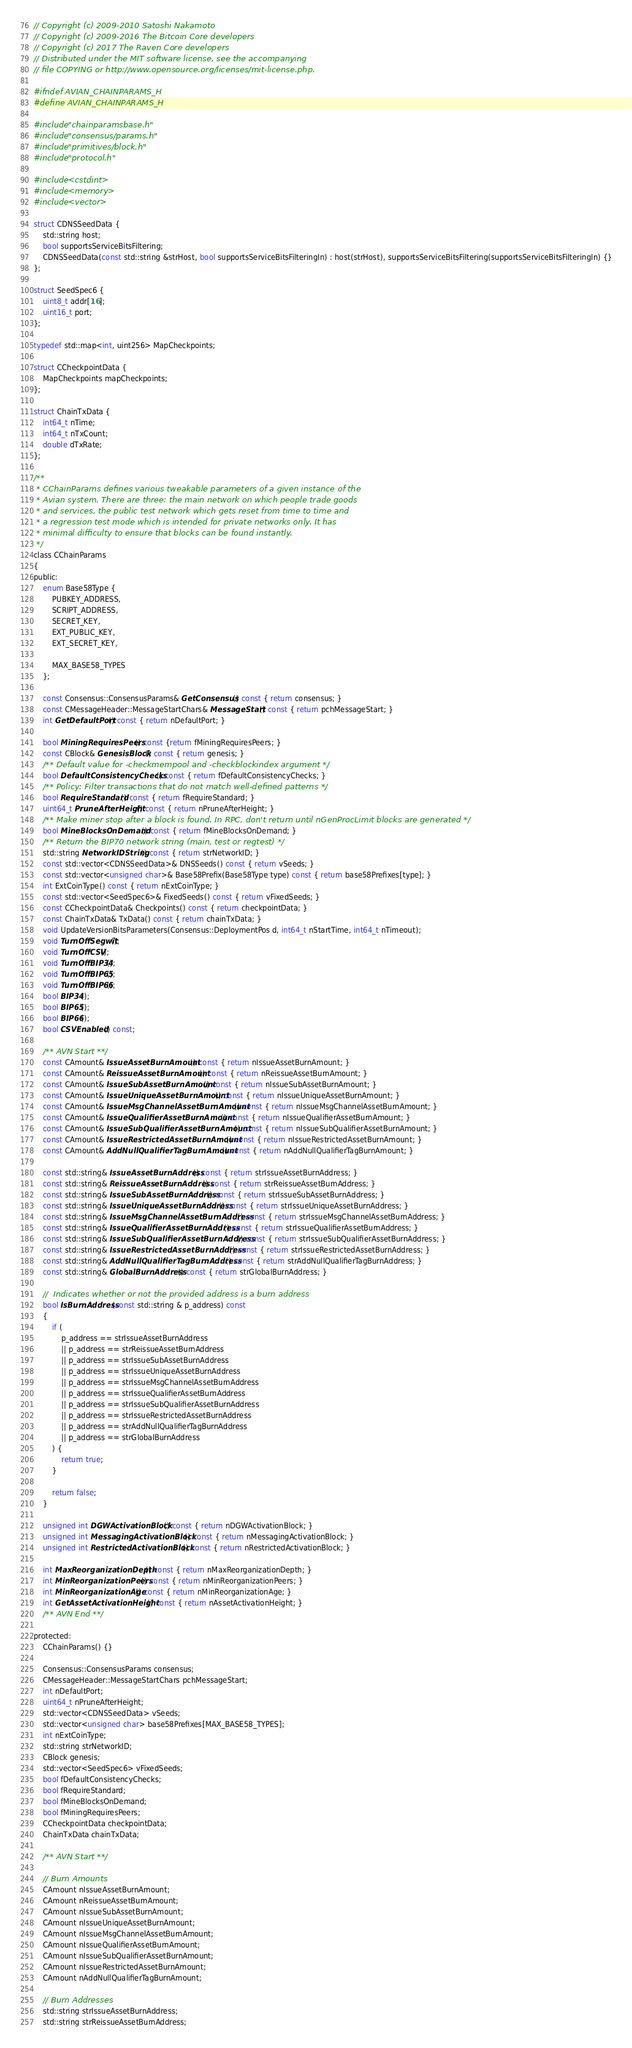<code> <loc_0><loc_0><loc_500><loc_500><_C_>// Copyright (c) 2009-2010 Satoshi Nakamoto
// Copyright (c) 2009-2016 The Bitcoin Core developers
// Copyright (c) 2017 The Raven Core developers
// Distributed under the MIT software license, see the accompanying
// file COPYING or http://www.opensource.org/licenses/mit-license.php.

#ifndef AVIAN_CHAINPARAMS_H
#define AVIAN_CHAINPARAMS_H

#include "chainparamsbase.h"
#include "consensus/params.h"
#include "primitives/block.h"
#include "protocol.h"

#include <cstdint>
#include <memory>
#include <vector>

struct CDNSSeedData {
    std::string host;
    bool supportsServiceBitsFiltering;
    CDNSSeedData(const std::string &strHost, bool supportsServiceBitsFilteringIn) : host(strHost), supportsServiceBitsFiltering(supportsServiceBitsFilteringIn) {}
};

struct SeedSpec6 {
    uint8_t addr[16];
    uint16_t port;
};

typedef std::map<int, uint256> MapCheckpoints;

struct CCheckpointData {
    MapCheckpoints mapCheckpoints;
};

struct ChainTxData {
    int64_t nTime;
    int64_t nTxCount;
    double dTxRate;
};

/**
 * CChainParams defines various tweakable parameters of a given instance of the
 * Avian system. There are three: the main network on which people trade goods
 * and services, the public test network which gets reset from time to time and
 * a regression test mode which is intended for private networks only. It has
 * minimal difficulty to ensure that blocks can be found instantly.
 */
class CChainParams
{
public:
    enum Base58Type {
        PUBKEY_ADDRESS,
        SCRIPT_ADDRESS,
        SECRET_KEY,
        EXT_PUBLIC_KEY,
        EXT_SECRET_KEY,

        MAX_BASE58_TYPES
    };

    const Consensus::ConsensusParams& GetConsensus() const { return consensus; }
    const CMessageHeader::MessageStartChars& MessageStart() const { return pchMessageStart; }
    int GetDefaultPort() const { return nDefaultPort; }

    bool MiningRequiresPeers() const {return fMiningRequiresPeers; }
    const CBlock& GenesisBlock() const { return genesis; }
    /** Default value for -checkmempool and -checkblockindex argument */
    bool DefaultConsistencyChecks() const { return fDefaultConsistencyChecks; }
    /** Policy: Filter transactions that do not match well-defined patterns */
    bool RequireStandard() const { return fRequireStandard; }
    uint64_t PruneAfterHeight() const { return nPruneAfterHeight; }
    /** Make miner stop after a block is found. In RPC, don't return until nGenProcLimit blocks are generated */
    bool MineBlocksOnDemand() const { return fMineBlocksOnDemand; }
    /** Return the BIP70 network string (main, test or regtest) */
    std::string NetworkIDString() const { return strNetworkID; }
    const std::vector<CDNSSeedData>& DNSSeeds() const { return vSeeds; }
    const std::vector<unsigned char>& Base58Prefix(Base58Type type) const { return base58Prefixes[type]; }
    int ExtCoinType() const { return nExtCoinType; }
    const std::vector<SeedSpec6>& FixedSeeds() const { return vFixedSeeds; }
    const CCheckpointData& Checkpoints() const { return checkpointData; }
    const ChainTxData& TxData() const { return chainTxData; }
    void UpdateVersionBitsParameters(Consensus::DeploymentPos d, int64_t nStartTime, int64_t nTimeout);
    void TurnOffSegwit();
    void TurnOffCSV();
    void TurnOffBIP34();
    void TurnOffBIP65();
    void TurnOffBIP66();
    bool BIP34();
    bool BIP65();
    bool BIP66();
    bool CSVEnabled() const;

    /** AVN Start **/
    const CAmount& IssueAssetBurnAmount() const { return nIssueAssetBurnAmount; }
    const CAmount& ReissueAssetBurnAmount() const { return nReissueAssetBurnAmount; }
    const CAmount& IssueSubAssetBurnAmount() const { return nIssueSubAssetBurnAmount; }
    const CAmount& IssueUniqueAssetBurnAmount() const { return nIssueUniqueAssetBurnAmount; }
    const CAmount& IssueMsgChannelAssetBurnAmount() const { return nIssueMsgChannelAssetBurnAmount; }
    const CAmount& IssueQualifierAssetBurnAmount() const { return nIssueQualifierAssetBurnAmount; }
    const CAmount& IssueSubQualifierAssetBurnAmount() const { return nIssueSubQualifierAssetBurnAmount; }
    const CAmount& IssueRestrictedAssetBurnAmount() const { return nIssueRestrictedAssetBurnAmount; }
    const CAmount& AddNullQualifierTagBurnAmount() const { return nAddNullQualifierTagBurnAmount; }

    const std::string& IssueAssetBurnAddress() const { return strIssueAssetBurnAddress; }
    const std::string& ReissueAssetBurnAddress() const { return strReissueAssetBurnAddress; }
    const std::string& IssueSubAssetBurnAddress() const { return strIssueSubAssetBurnAddress; }
    const std::string& IssueUniqueAssetBurnAddress() const { return strIssueUniqueAssetBurnAddress; }
    const std::string& IssueMsgChannelAssetBurnAddress() const { return strIssueMsgChannelAssetBurnAddress; }
    const std::string& IssueQualifierAssetBurnAddress() const { return strIssueQualifierAssetBurnAddress; }
    const std::string& IssueSubQualifierAssetBurnAddress() const { return strIssueSubQualifierAssetBurnAddress; }
    const std::string& IssueRestrictedAssetBurnAddress() const { return strIssueRestrictedAssetBurnAddress; }
    const std::string& AddNullQualifierTagBurnAddress() const { return strAddNullQualifierTagBurnAddress; }
    const std::string& GlobalBurnAddress() const { return strGlobalBurnAddress; }

    //  Indicates whether or not the provided address is a burn address
    bool IsBurnAddress(const std::string & p_address) const
    {
        if (
            p_address == strIssueAssetBurnAddress
            || p_address == strReissueAssetBurnAddress
            || p_address == strIssueSubAssetBurnAddress
            || p_address == strIssueUniqueAssetBurnAddress
            || p_address == strIssueMsgChannelAssetBurnAddress
            || p_address == strIssueQualifierAssetBurnAddress
            || p_address == strIssueSubQualifierAssetBurnAddress
            || p_address == strIssueRestrictedAssetBurnAddress
            || p_address == strAddNullQualifierTagBurnAddress
            || p_address == strGlobalBurnAddress
        ) {
            return true;
        }

        return false;
    }

    unsigned int DGWActivationBlock() const { return nDGWActivationBlock; }
    unsigned int MessagingActivationBlock() const { return nMessagingActivationBlock; }
    unsigned int RestrictedActivationBlock() const { return nRestrictedActivationBlock; }

    int MaxReorganizationDepth() const { return nMaxReorganizationDepth; }
    int MinReorganizationPeers() const { return nMinReorganizationPeers; }
    int MinReorganizationAge() const { return nMinReorganizationAge; }
    int GetAssetActivationHeight() const { return nAssetActivationHeight; }
    /** AVN End **/

protected:
    CChainParams() {}

    Consensus::ConsensusParams consensus;
    CMessageHeader::MessageStartChars pchMessageStart;
    int nDefaultPort;
    uint64_t nPruneAfterHeight;
    std::vector<CDNSSeedData> vSeeds;
    std::vector<unsigned char> base58Prefixes[MAX_BASE58_TYPES];
    int nExtCoinType;
    std::string strNetworkID;
    CBlock genesis;
    std::vector<SeedSpec6> vFixedSeeds;
    bool fDefaultConsistencyChecks;
    bool fRequireStandard;
    bool fMineBlocksOnDemand;
    bool fMiningRequiresPeers;
    CCheckpointData checkpointData;
    ChainTxData chainTxData;

    /** AVN Start **/

    // Burn Amounts
    CAmount nIssueAssetBurnAmount;
    CAmount nReissueAssetBurnAmount;
    CAmount nIssueSubAssetBurnAmount;
    CAmount nIssueUniqueAssetBurnAmount;
    CAmount nIssueMsgChannelAssetBurnAmount;
    CAmount nIssueQualifierAssetBurnAmount;
    CAmount nIssueSubQualifierAssetBurnAmount;
    CAmount nIssueRestrictedAssetBurnAmount;
    CAmount nAddNullQualifierTagBurnAmount;

    // Burn Addresses
    std::string strIssueAssetBurnAddress;
    std::string strReissueAssetBurnAddress;</code> 